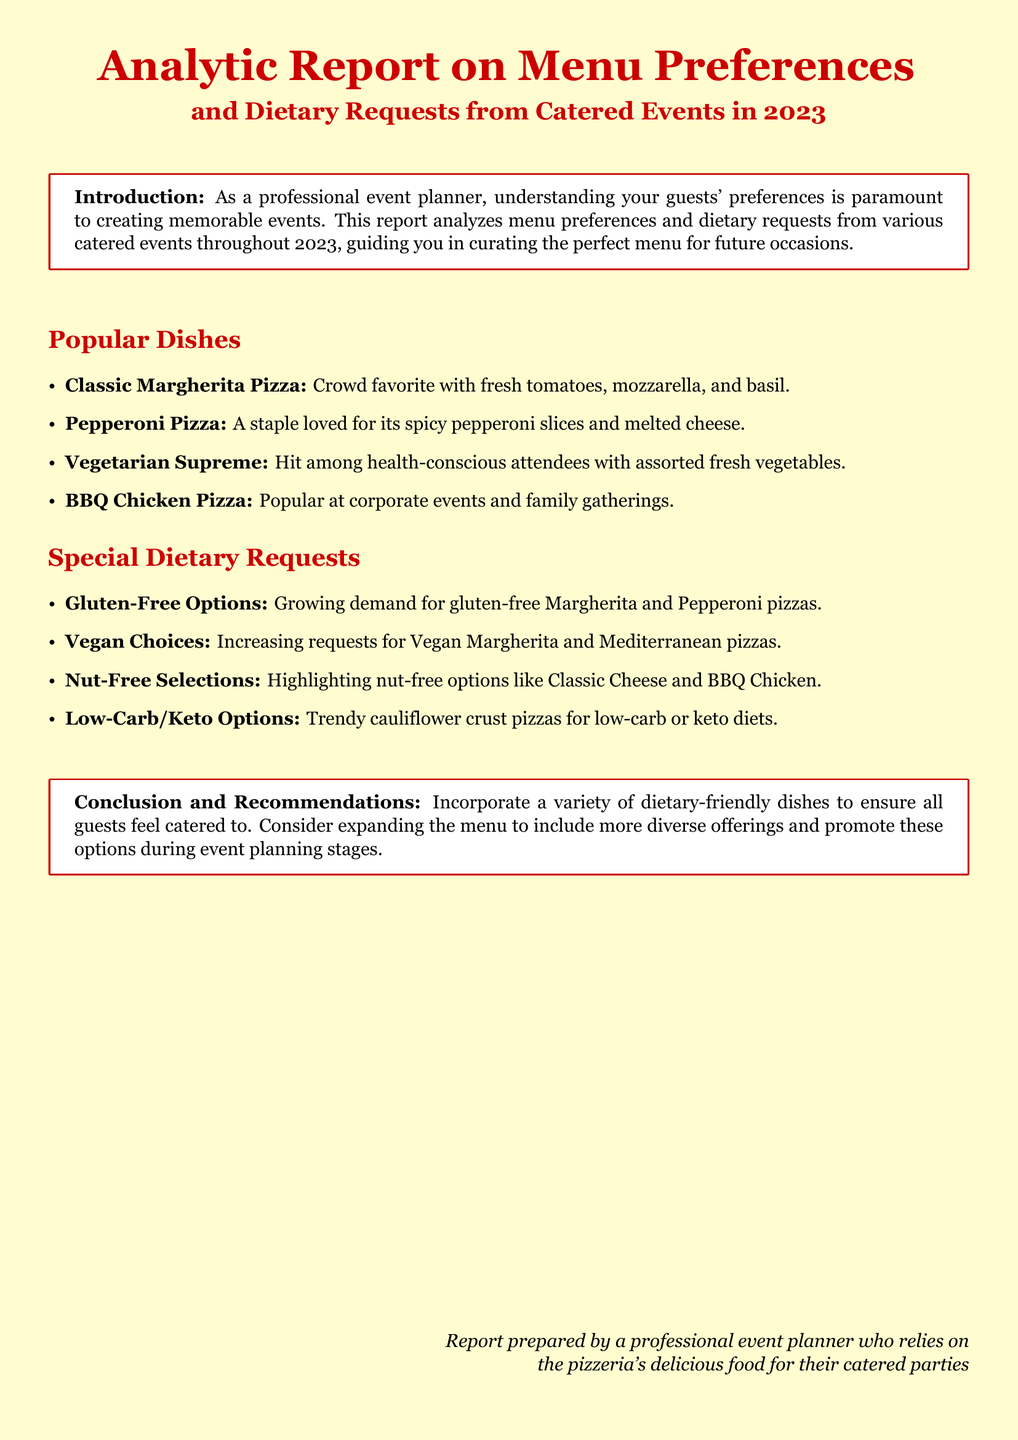What is the title of the report? The title provides an overview of the content of the document, which is focused on menu preferences and dietary requests for catered events.
Answer: Analytic Report on Menu Preferences and Dietary Requests from Catered Events in 2023 What is a popular vegetarian option listed? This question asks for a specific dish categorized as popular among health-conscious attendees, as stated in the document.
Answer: Vegetarian Supreme How many special dietary requests are mentioned? Counting the special dietary requests gives clarity on the variety of options being addressed in the report.
Answer: Four What is a gluten-free option that is growing in demand? This asks for a specific dish that meets gluten-free dietary needs, highlighting the menu adaptations.
Answer: Gluten-free Margherita Which dish is a staple loved for spicy slices? This question targets a specific popular dish that features a recognized ingredient associated with its appeal.
Answer: Pepperoni Pizza What does the report recommend for future events? The recommendations section offers insights for improvement based on the analysis of the data.
Answer: Incorporate a variety of dietary-friendly dishes What color is used for the main title in the document? Identifying the color used for the title provides insight into the visual branding of the report.
Answer: Pizzared What dish is highlighted as trendy for low-carb diets? This question addresses the mention of dietary trends specific to low-carb or keto diets within the menu options.
Answer: Cauliflower crust pizzas 